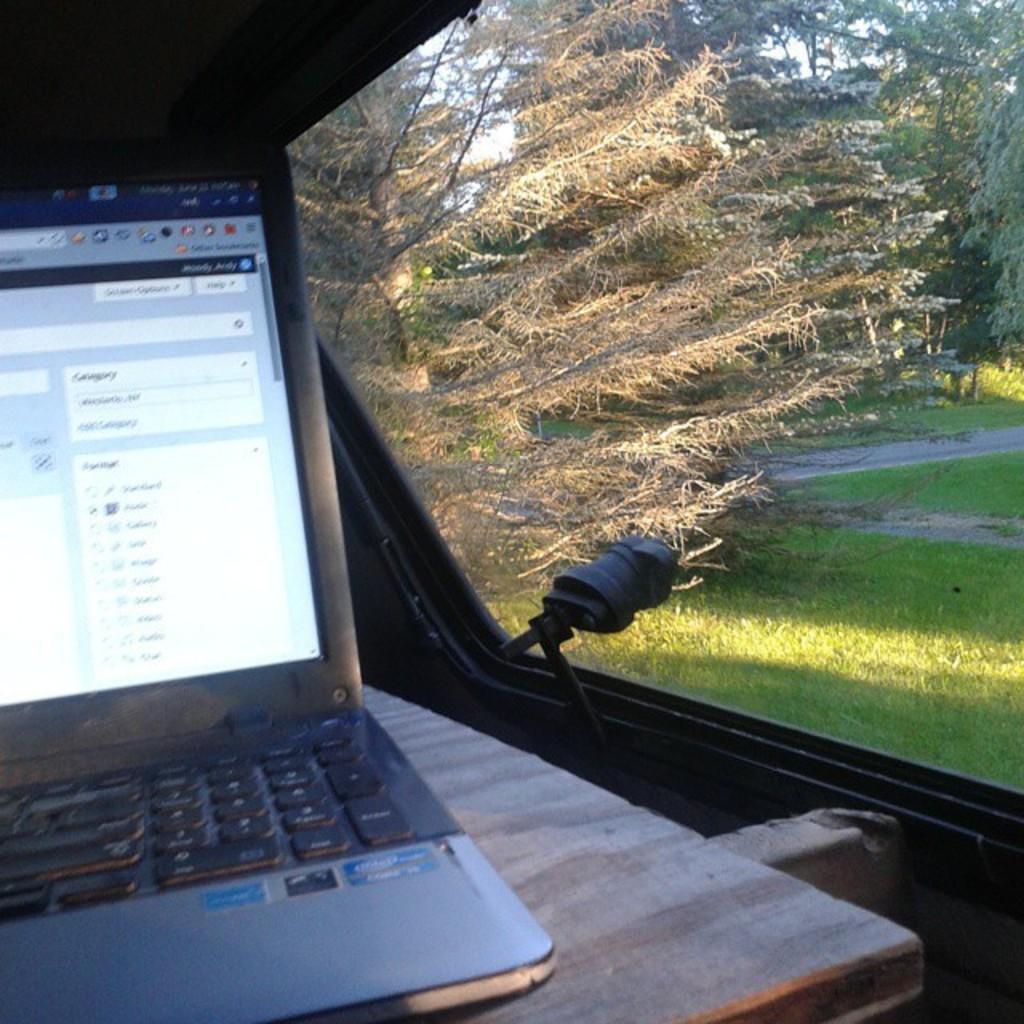In one or two sentences, can you explain what this image depicts? In the image we can see there is a laptop kept on the table and there is a window. Behind there is a ground covered with grass and there are lot of trees. 